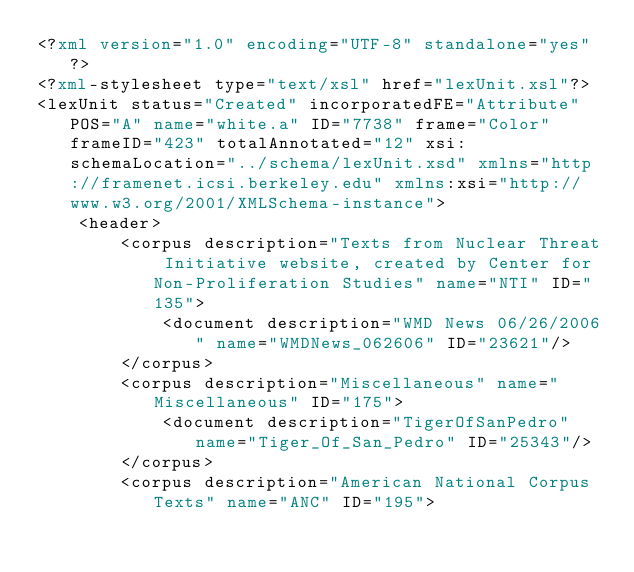<code> <loc_0><loc_0><loc_500><loc_500><_XML_><?xml version="1.0" encoding="UTF-8" standalone="yes"?>
<?xml-stylesheet type="text/xsl" href="lexUnit.xsl"?>
<lexUnit status="Created" incorporatedFE="Attribute" POS="A" name="white.a" ID="7738" frame="Color" frameID="423" totalAnnotated="12" xsi:schemaLocation="../schema/lexUnit.xsd" xmlns="http://framenet.icsi.berkeley.edu" xmlns:xsi="http://www.w3.org/2001/XMLSchema-instance">
    <header>
        <corpus description="Texts from Nuclear Threat Initiative website, created by Center for Non-Proliferation Studies" name="NTI" ID="135">
            <document description="WMD News 06/26/2006" name="WMDNews_062606" ID="23621"/>
        </corpus>
        <corpus description="Miscellaneous" name="Miscellaneous" ID="175">
            <document description="TigerOfSanPedro" name="Tiger_Of_San_Pedro" ID="25343"/>
        </corpus>
        <corpus description="American National Corpus Texts" name="ANC" ID="195"></code> 